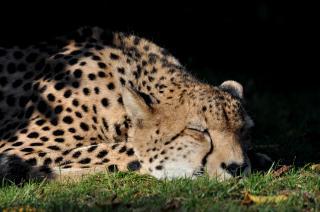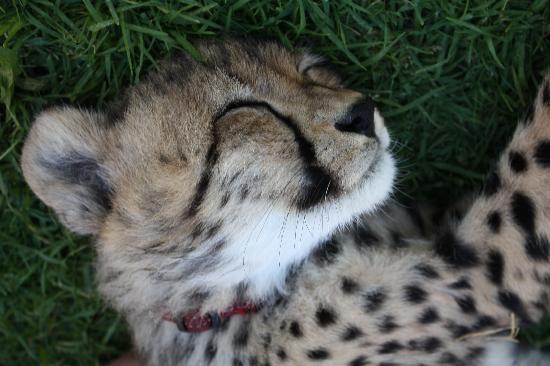The first image is the image on the left, the second image is the image on the right. For the images displayed, is the sentence "At least one animal is sleeping in a tree." factually correct? Answer yes or no. No. 